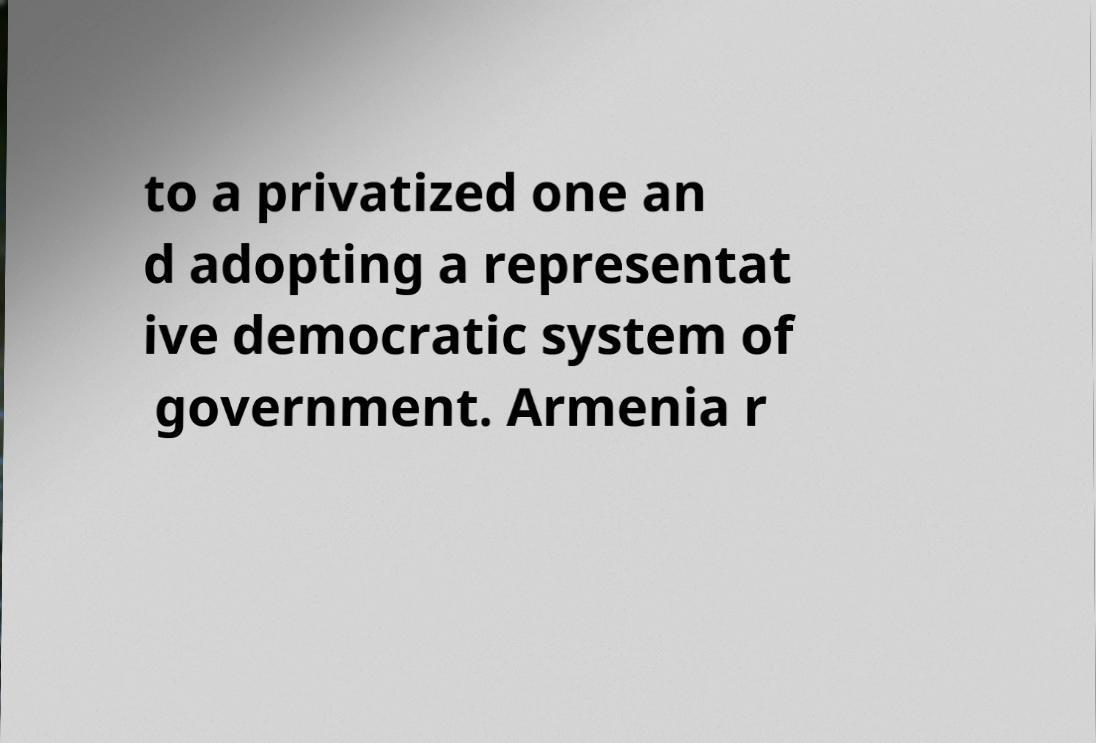Can you read and provide the text displayed in the image?This photo seems to have some interesting text. Can you extract and type it out for me? to a privatized one an d adopting a representat ive democratic system of government. Armenia r 